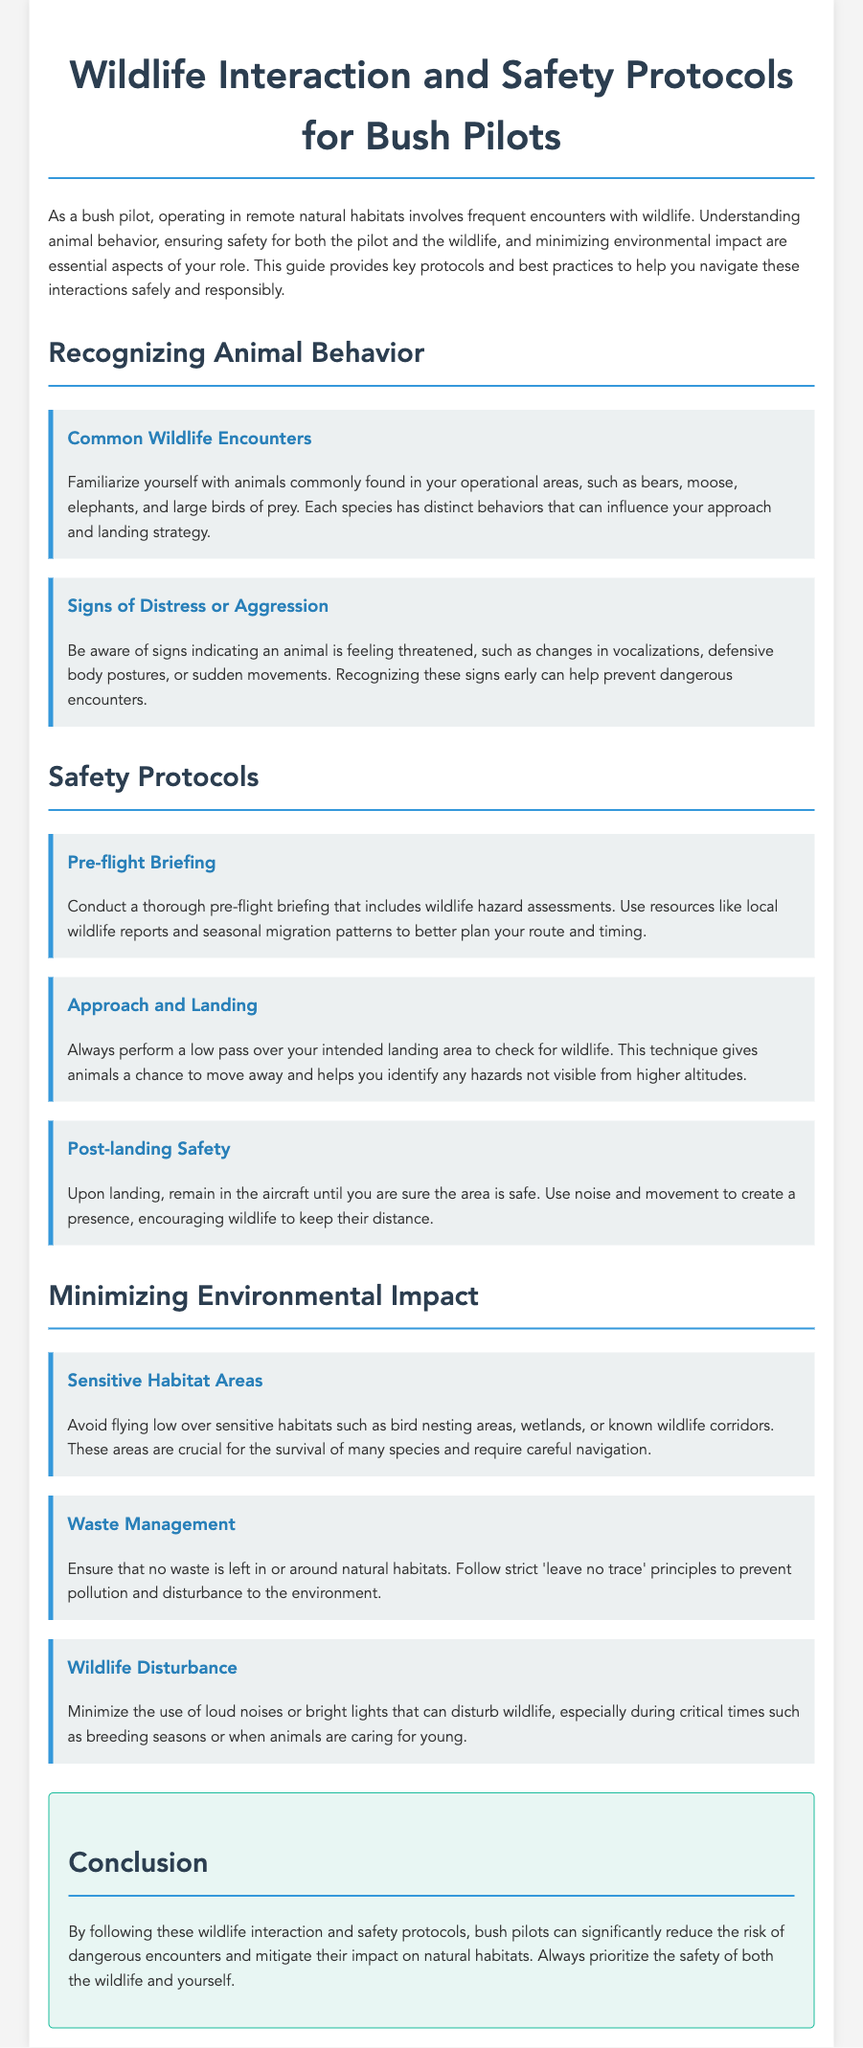what are common wildlife encounters mentioned in the document? The document lists bears, moose, elephants, and large birds of prey as common wildlife encounters for bush pilots.
Answer: bears, moose, elephants, large birds of prey what should you do during a low pass over the landing area? A low pass allows you to check for wildlife and gives animals a chance to move away, helping identify hazards.
Answer: check for wildlife what is one sign of animal distress? Distress can be indicated by changes in vocalizations, defensive body postures, or sudden movements.
Answer: changes in vocalizations what principle should be followed for waste management? The document states that bush pilots should follow strict 'leave no trace' principles to prevent pollution and disturbance.
Answer: leave no trace what should you do upon landing to ensure safety? The protocol advises remaining in the aircraft until the area is confirmed safe to avoid potential risks from wildlife.
Answer: remain in the aircraft which areas should be avoided when flying low? Sensitive habitats including bird nesting areas, wetlands, or known wildlife corridors should be avoided.
Answer: Sensitive habitats how can pilots minimize disturbance to wildlife? Limiting the use of loud noises or bright lights during critical times, like breeding seasons, can help minimize disturbance.
Answer: minimize loud noises what is the goal of conducting a pre-flight briefing? The main goal is to assess wildlife hazards to plan the route and timing effectively.
Answer: wildlife hazard assessments 